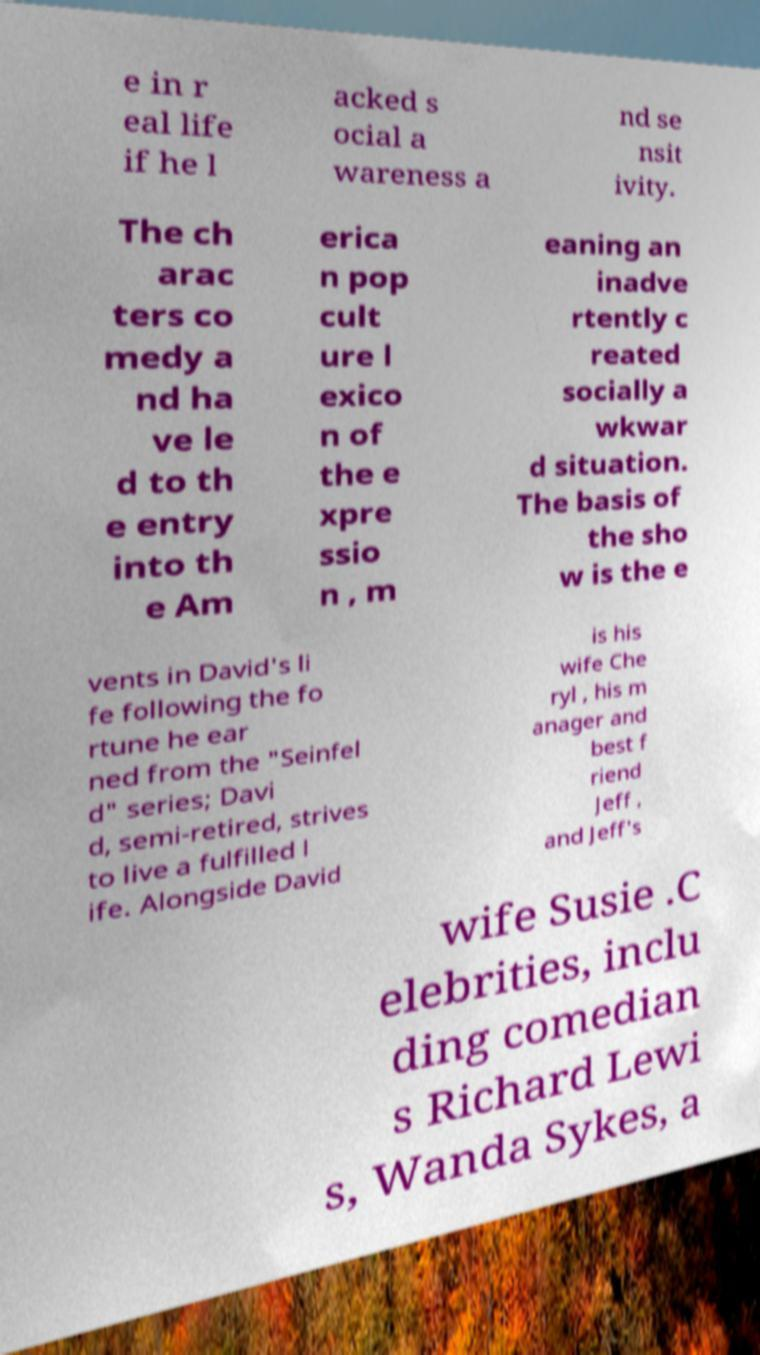I need the written content from this picture converted into text. Can you do that? e in r eal life if he l acked s ocial a wareness a nd se nsit ivity. The ch arac ters co medy a nd ha ve le d to th e entry into th e Am erica n pop cult ure l exico n of the e xpre ssio n , m eaning an inadve rtently c reated socially a wkwar d situation. The basis of the sho w is the e vents in David's li fe following the fo rtune he ear ned from the "Seinfel d" series; Davi d, semi-retired, strives to live a fulfilled l ife. Alongside David is his wife Che ryl , his m anager and best f riend Jeff , and Jeff's wife Susie .C elebrities, inclu ding comedian s Richard Lewi s, Wanda Sykes, a 